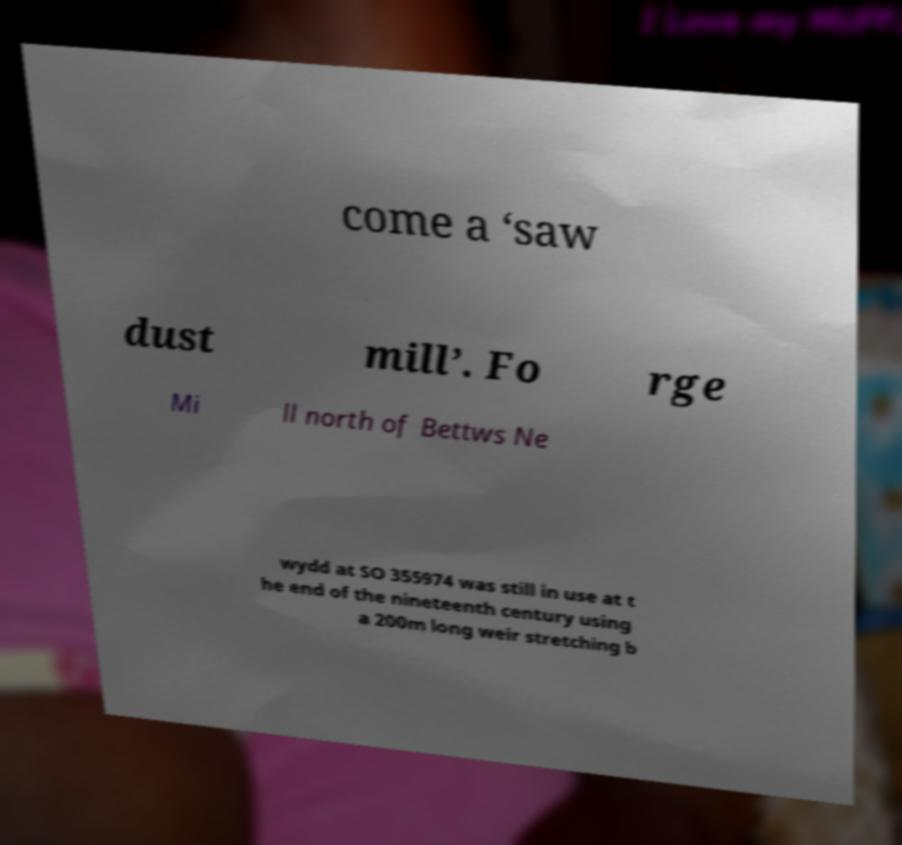Could you assist in decoding the text presented in this image and type it out clearly? come a ‘saw dust mill’. Fo rge Mi ll north of Bettws Ne wydd at SO 355974 was still in use at t he end of the nineteenth century using a 200m long weir stretching b 